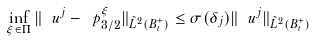Convert formula to latex. <formula><loc_0><loc_0><loc_500><loc_500>\inf _ { \xi \in \Pi } \| \ u ^ { j } - \ p _ { 3 / 2 } ^ { \xi } \| _ { \tilde { L } ^ { 2 } ( B _ { t } ^ { + } ) } \leq \sigma ( \delta _ { j } ) \| \ u ^ { j } \| _ { \tilde { L } ^ { 2 } ( B _ { t } ^ { + } ) }</formula> 